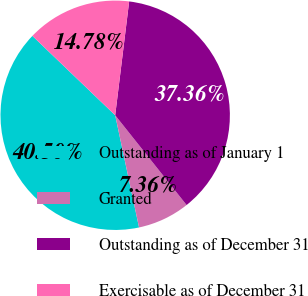Convert chart. <chart><loc_0><loc_0><loc_500><loc_500><pie_chart><fcel>Outstanding as of January 1<fcel>Granted<fcel>Outstanding as of December 31<fcel>Exercisable as of December 31<nl><fcel>40.5%<fcel>7.36%<fcel>37.36%<fcel>14.78%<nl></chart> 